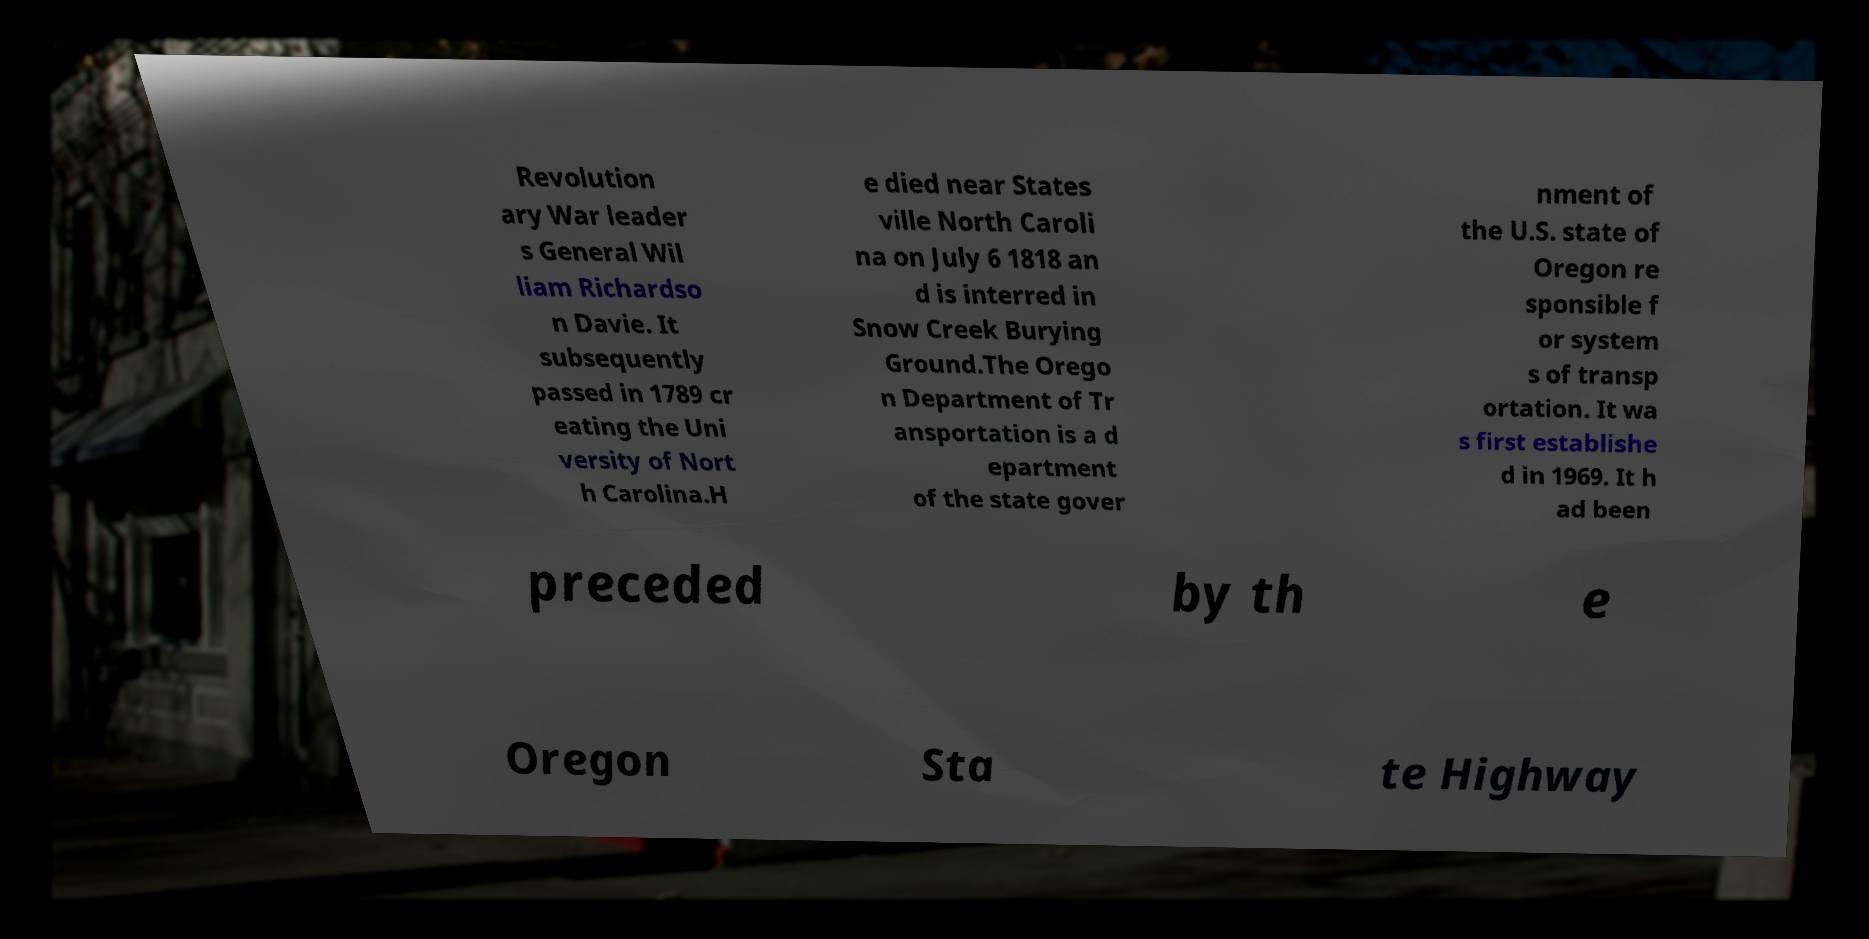Could you assist in decoding the text presented in this image and type it out clearly? Revolution ary War leader s General Wil liam Richardso n Davie. It subsequently passed in 1789 cr eating the Uni versity of Nort h Carolina.H e died near States ville North Caroli na on July 6 1818 an d is interred in Snow Creek Burying Ground.The Orego n Department of Tr ansportation is a d epartment of the state gover nment of the U.S. state of Oregon re sponsible f or system s of transp ortation. It wa s first establishe d in 1969. It h ad been preceded by th e Oregon Sta te Highway 